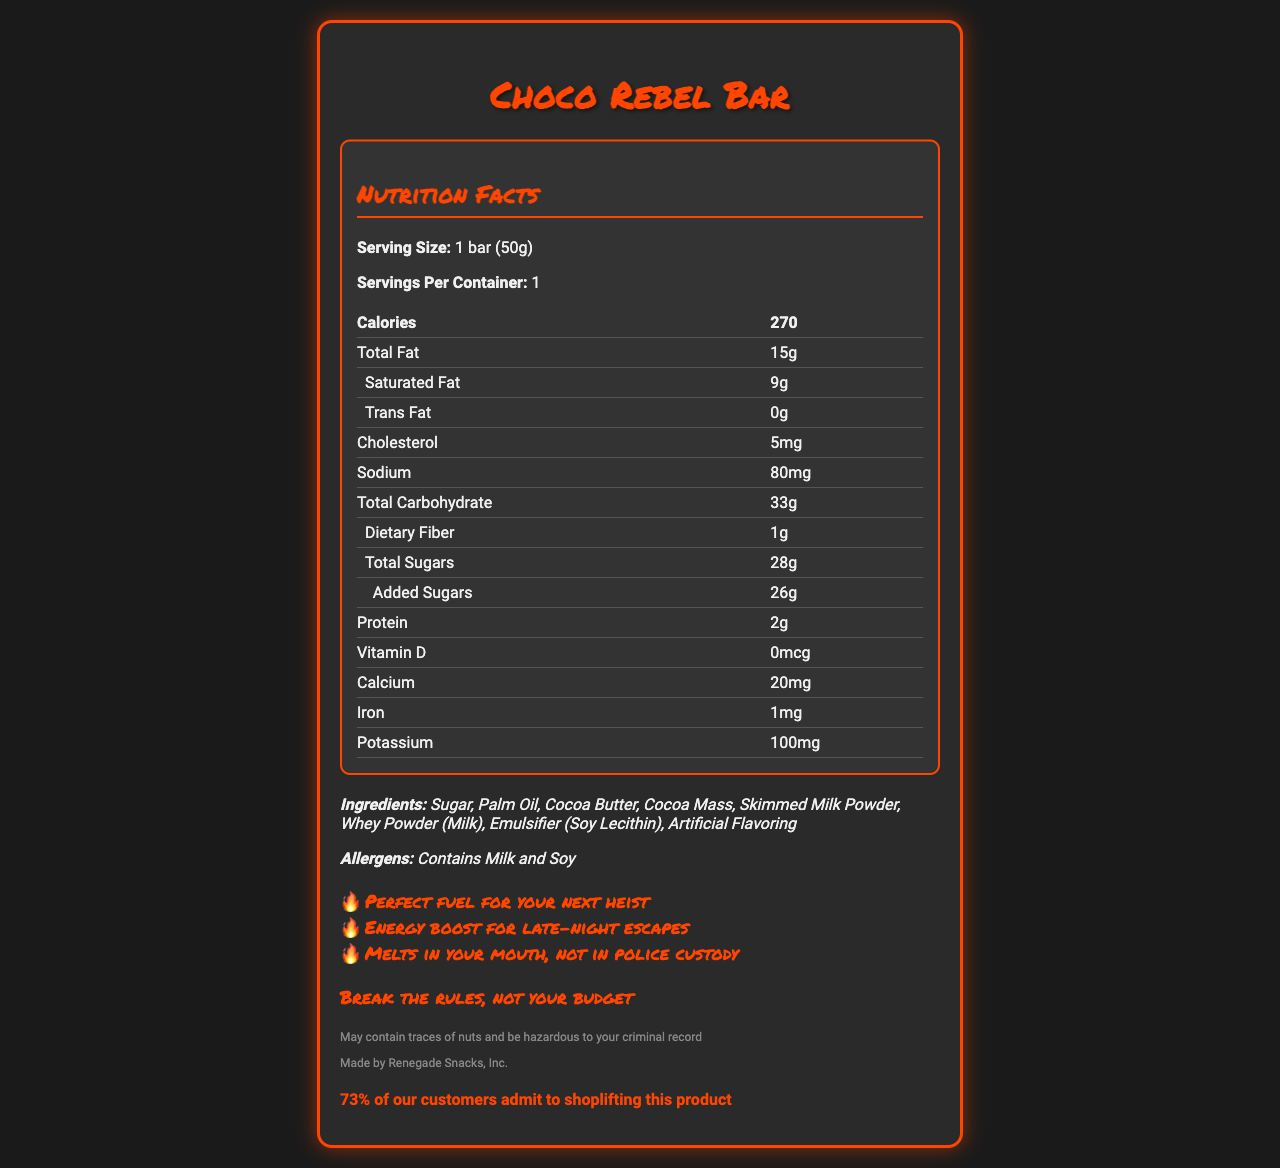what is the serving size of the Choco Rebel Bar? The serving size is directly mentioned in the Nutrition Facts section of the document as "1 bar (50g)".
Answer: 1 bar (50g) How many grams of saturated fat are there in one Choco Rebel Bar? The document lists saturated fat content as 9 grams in the Nutrition Facts.
Answer: 9g What is the amount of added sugars in the Choco Rebel Bar? The total added sugars content is listed as 26 grams under the Total Sugars section of the Nutrition Facts.
Answer: 26g Which ingredients contain milk in the Choco Rebel Bar? The ingredients list includes Skimmed Milk Powder and Whey Powder (Milk), both of which contain milk.
Answer: Skimmed Milk Powder, Whey Powder (Milk) Who is the manufacturer of the Choco Rebel Bar? The manufacturer information is provided in the disclaimer section of the document as "Made by Renegade Snacks, Inc."
Answer: Renegade Snacks, Inc. How many calories are in one Choco Rebel Bar? The number of calories per serving is listed as 270 in the Nutrition Facts section.
Answer: 270 What is the total fat content in the Choco Rebel Bar? The total fat content is indicated in the Nutrition Facts as 15 grams.
Answer: 15g Does the Choco Rebel Bar contain any potassium? The Nutrition Facts section lists potassium content as 100mg, indicating that the bar does contain potassium.
Answer: Yes What percentage of customers admit to shoplifting this product? A. 23% B. 50% C. 73% D. 80% The document states that "73% of our customers admit to shoplifting this product" in the stolen percentage section.
Answer: C. 73% How much dietary fiber is present in the Choco Rebel Bar? The dietary fiber content is specified as 1 gram in the Nutrition Facts.
Answer: 1g What is the brand slogan of the Choco Rebel Bar? A. Snack with Confidence B. Dare to Indulge C. Break the rules, not your budget D. Taste the Freedom The document mentions the brand slogan as "Break the rules, not your budget".
Answer: C. Break the rules, not your budget Is the Choco Rebel Bar suitable for someone with a nut allergy? The legal disclaimer mentions that the product "May contain traces of nuts," so it is not suitable for someone with a nut allergy.
Answer: No Summarize the main idea of the Choco Rebel Bar's nutrition facts document. The document provides a full breakdown of the nutritional elements per serving, lists ingredients and possible allergens, and uses a rebellious marketing tone. Key health-related details like high sugar and saturated fat content are prominently displayed, and the document is styled to match the rebellious theme of the brand.
Answer: The Choco Rebel Bar's nutrition facts document provides detailed information about its serving size, calorie count, and nutritional content, including high levels of sugar and saturated fat. It lists ingredients and allergens, includes marketing claims, a brand slogan, and captures attention with an unusual disclaimer and a note on shoplifting statistics. What is the total carbohydrate content of the Choco Rebel Bar, including dietary fiber and total sugars? The document lists 33 grams as the total carbohydrate content, which includes dietary fiber and total sugars.
Answer: 33g What energy boost does the Choco Rebel Bar claim to provide? One of the marketing claims for the Choco Rebel Bar is "Energy boost for late-night escapes".
Answer: Energy boost for late-night escapes What is the artificial flavoring mentioned in the ingredients list? The document does not specify what the artificial flavoring is. The ingredients list only mentions "Artificial Flavoring" without further details.
Answer: Cannot be determined How much sodium is in a serving of the Choco Rebel Bar? The amount of sodium per serving is listed as 80mg in the Nutrition Facts.
Answer: 80mg What is the percentage of the daily value for cholesterol provided by one Choco Rebel Bar? The document does not include the percentage of the daily value for cholesterol. It only lists the cholesterol content as 5mg.
Answer: Not enough information 